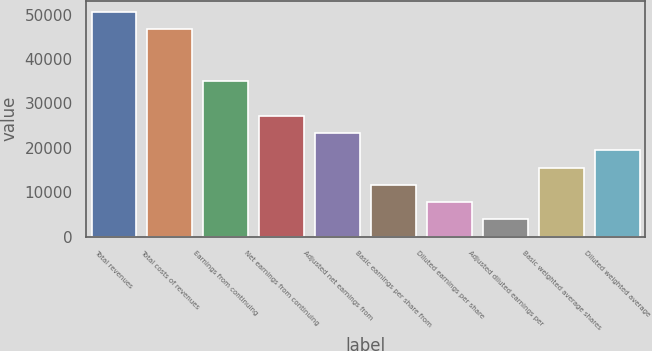<chart> <loc_0><loc_0><loc_500><loc_500><bar_chart><fcel>Total revenues<fcel>Total costs of revenues<fcel>Earnings from continuing<fcel>Net earnings from continuing<fcel>Adjusted net earnings from<fcel>Basic earnings per share from<fcel>Diluted earnings per share<fcel>Adjusted diluted earnings per<fcel>Basic weighted average shares<fcel>Diluted weighted average<nl><fcel>50552.2<fcel>46663.8<fcel>34998.4<fcel>27221.5<fcel>23333<fcel>11667.6<fcel>7779.16<fcel>3890.7<fcel>15556.1<fcel>19444.5<nl></chart> 